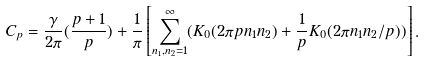<formula> <loc_0><loc_0><loc_500><loc_500>C _ { p } = \frac { \gamma } { 2 \pi } ( \frac { p + 1 } { p } ) + \frac { 1 } { \pi } \left [ \sum _ { n _ { 1 } , n _ { 2 } = 1 } ^ { \infty } ( K _ { 0 } ( 2 \pi p n _ { 1 } n _ { 2 } ) + \frac { 1 } { p } K _ { 0 } ( 2 \pi n _ { 1 } n _ { 2 } / p ) ) \right ] .</formula> 